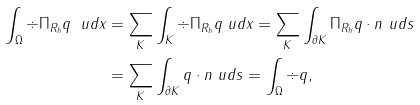<formula> <loc_0><loc_0><loc_500><loc_500>\int _ { \Omega } \div \Pi _ { R _ { h } } q \ u d x & = \sum _ { K } \int _ { K } \div \Pi _ { R _ { h } } q \ u d x = \sum _ { K } \int _ { \partial K } \Pi _ { R _ { h } } q \cdot n \ u d s \\ & = \sum _ { K } \int _ { \partial K } q \cdot n \ u d s = \int _ { \Omega } \div q ,</formula> 